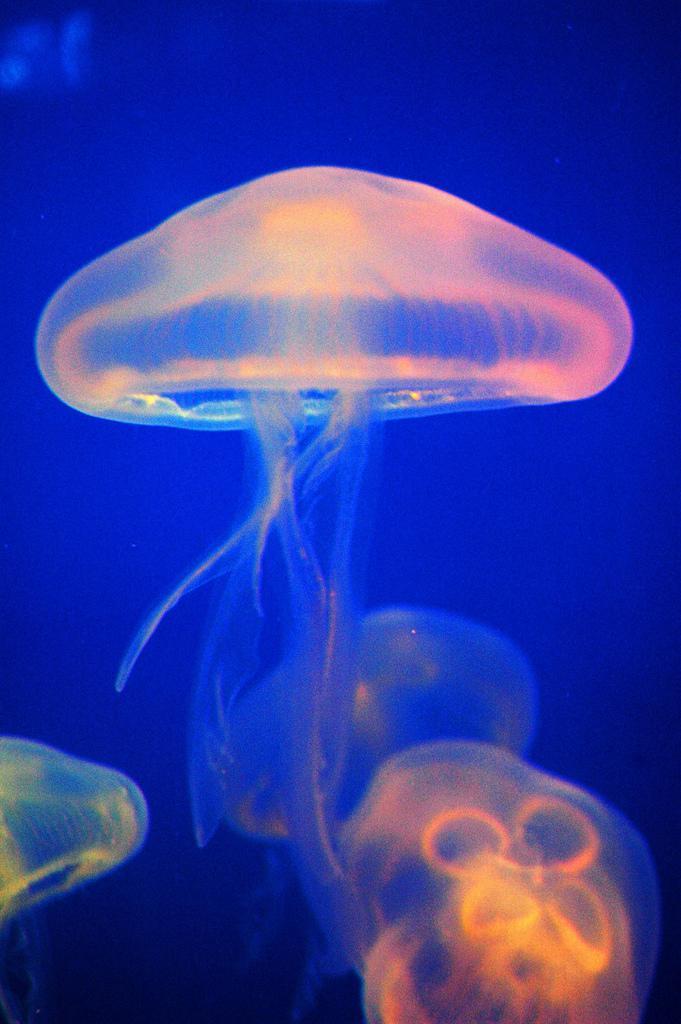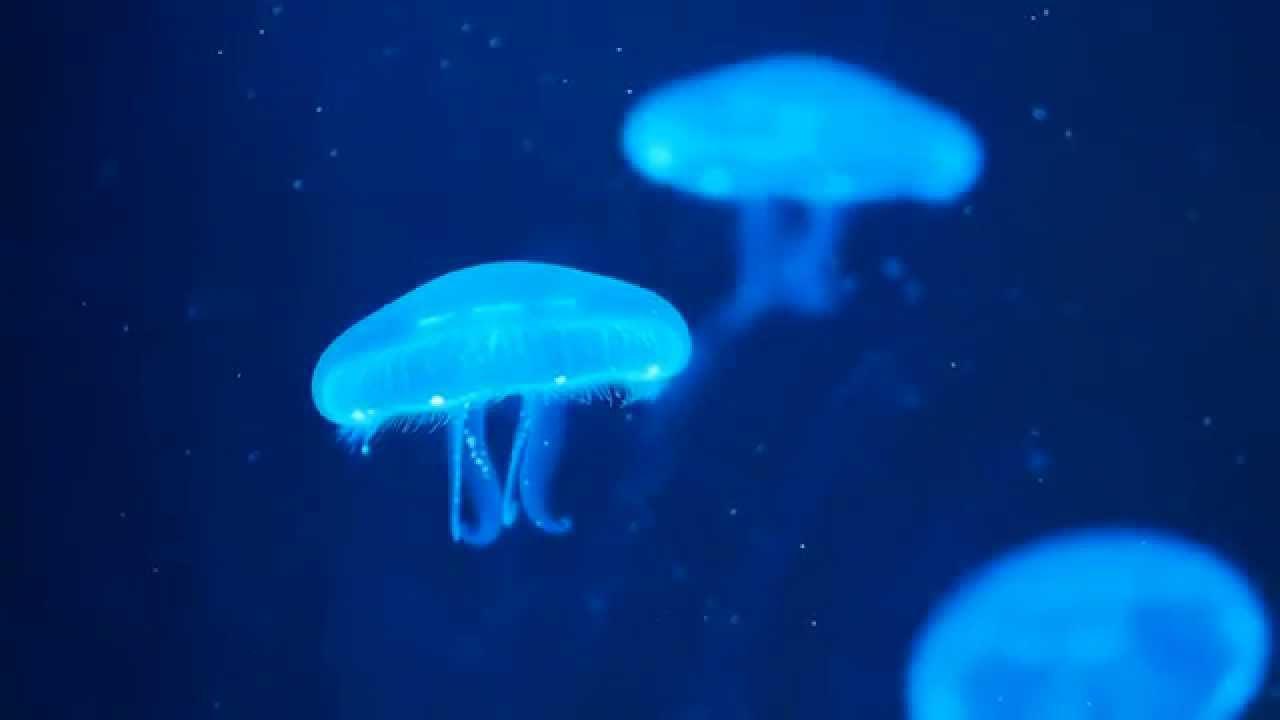The first image is the image on the left, the second image is the image on the right. Examine the images to the left and right. Is the description "There are at least 20 sea creatures in one of the images." accurate? Answer yes or no. No. 